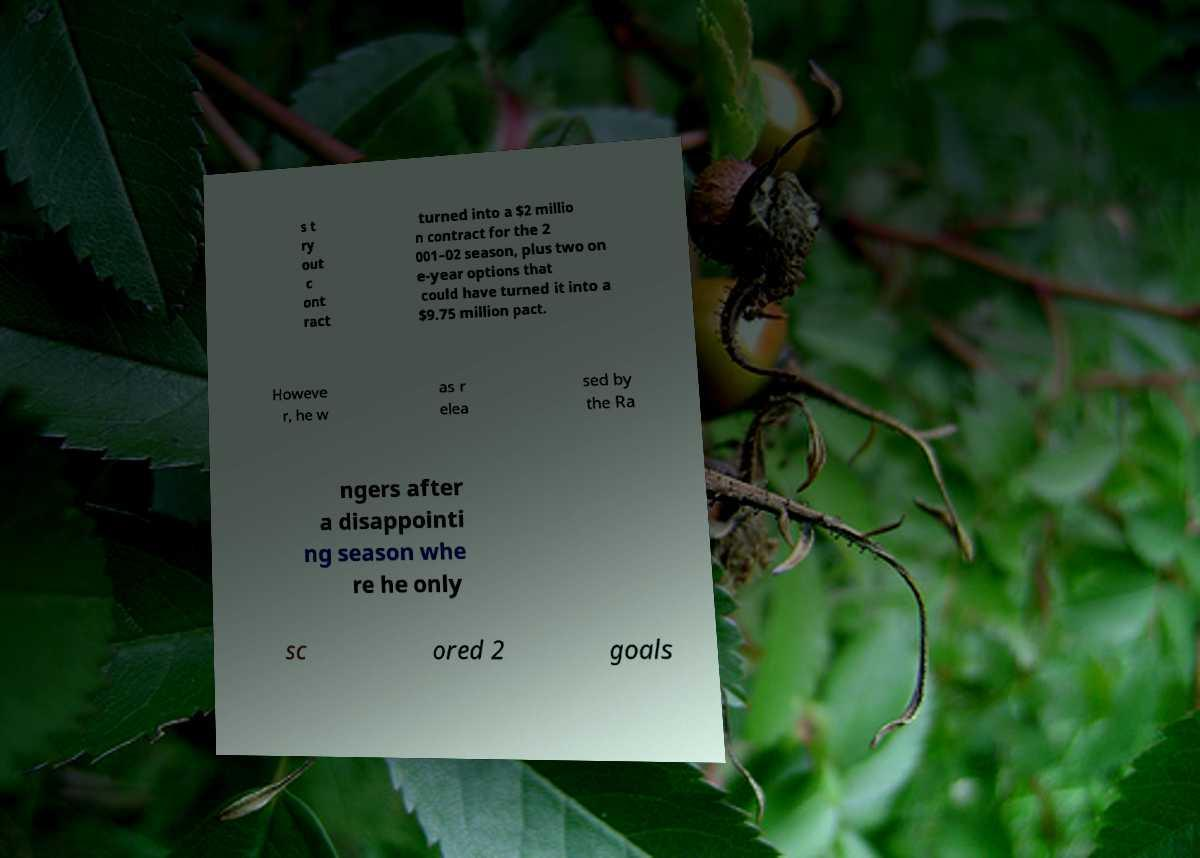Can you accurately transcribe the text from the provided image for me? s t ry out c ont ract turned into a $2 millio n contract for the 2 001–02 season, plus two on e-year options that could have turned it into a $9.75 million pact. Howeve r, he w as r elea sed by the Ra ngers after a disappointi ng season whe re he only sc ored 2 goals 